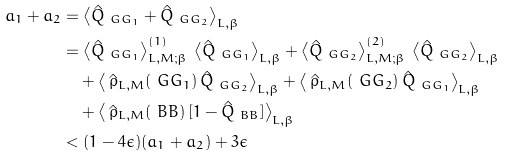Convert formula to latex. <formula><loc_0><loc_0><loc_500><loc_500>a _ { 1 } + a _ { 2 } & = \left \langle \hat { Q } _ { \ G G _ { 1 } } + \hat { Q } _ { \ G G _ { 2 } } \right \rangle _ { L , \beta } \\ & = \left \langle \hat { Q } _ { \ G G _ { 1 } } \right \rangle _ { L , M ; \beta } ^ { ( 1 ) } \, \left \langle \hat { Q } _ { \ G G _ { 1 } } \right \rangle _ { L , \beta } + \left \langle \hat { Q } _ { \ G G _ { 2 } } \right \rangle _ { L , M ; \beta } ^ { ( 2 ) } \, \left \langle \hat { Q } _ { \ G G _ { 2 } } \right \rangle _ { L , \beta } \\ & \quad + \left \langle \, \hat { \rho } _ { L , M } ( \ G G _ { 1 } ) \, \hat { Q } _ { \ G G _ { 2 } } \right \rangle _ { L , \beta } + \left \langle \, \hat { \rho } _ { L , M } ( \ G G _ { 2 } ) \, \hat { Q } _ { \ G G _ { 1 } } \right \rangle _ { L , \beta } \\ & \quad + \left \langle \, \hat { \rho } _ { L , M } ( \ B B ) \, [ 1 - \hat { Q } _ { \ B B } ] \right \rangle _ { L , \beta } \\ & < ( 1 - 4 \epsilon ) ( a _ { 1 } + a _ { 2 } ) + 3 \epsilon</formula> 